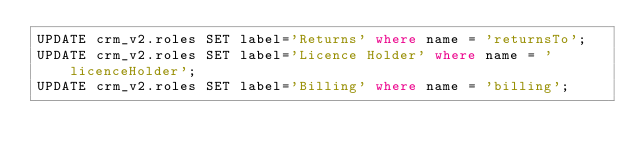<code> <loc_0><loc_0><loc_500><loc_500><_SQL_>UPDATE crm_v2.roles SET label='Returns' where name = 'returnsTo';
UPDATE crm_v2.roles SET label='Licence Holder' where name = 'licenceHolder';
UPDATE crm_v2.roles SET label='Billing' where name = 'billing';
</code> 